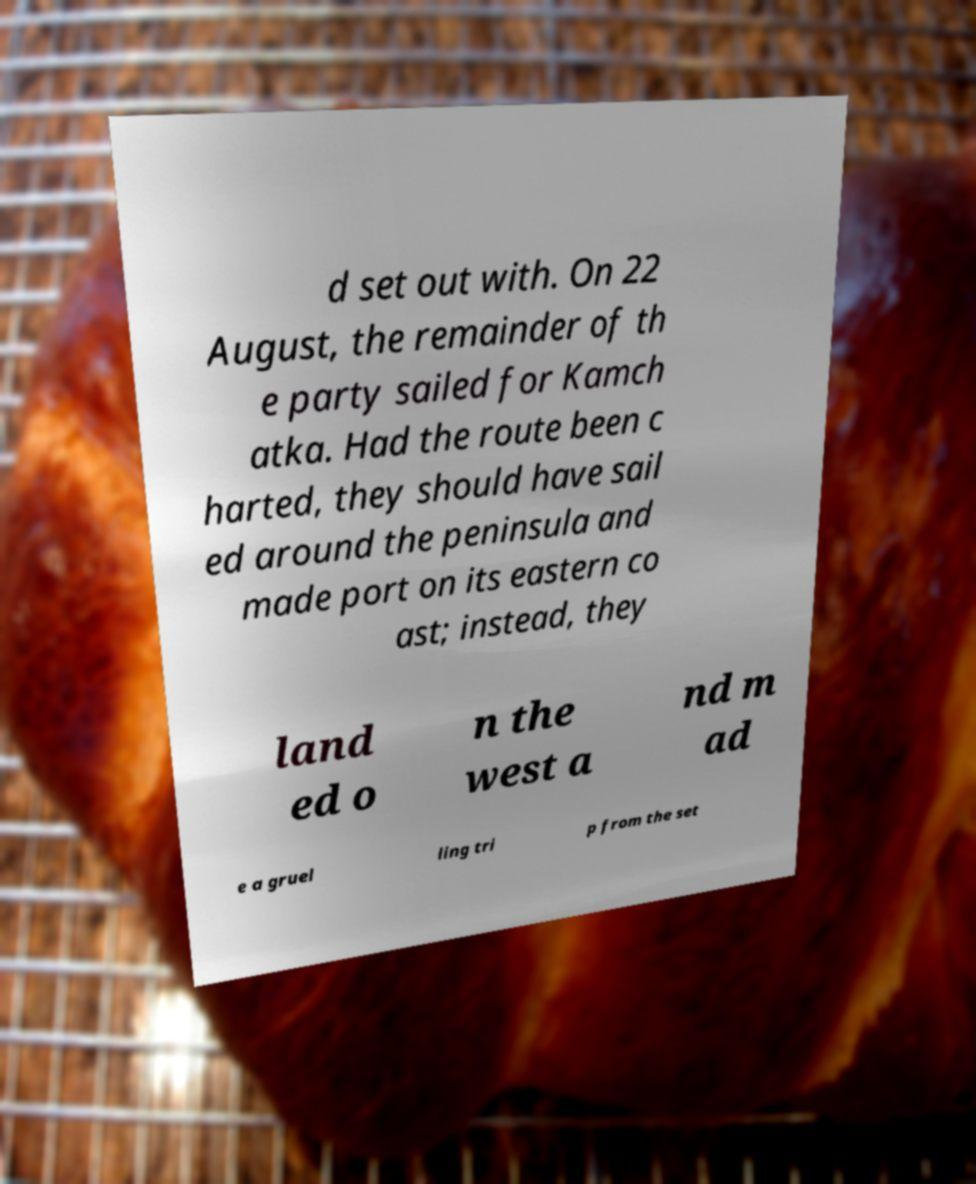Could you assist in decoding the text presented in this image and type it out clearly? d set out with. On 22 August, the remainder of th e party sailed for Kamch atka. Had the route been c harted, they should have sail ed around the peninsula and made port on its eastern co ast; instead, they land ed o n the west a nd m ad e a gruel ling tri p from the set 